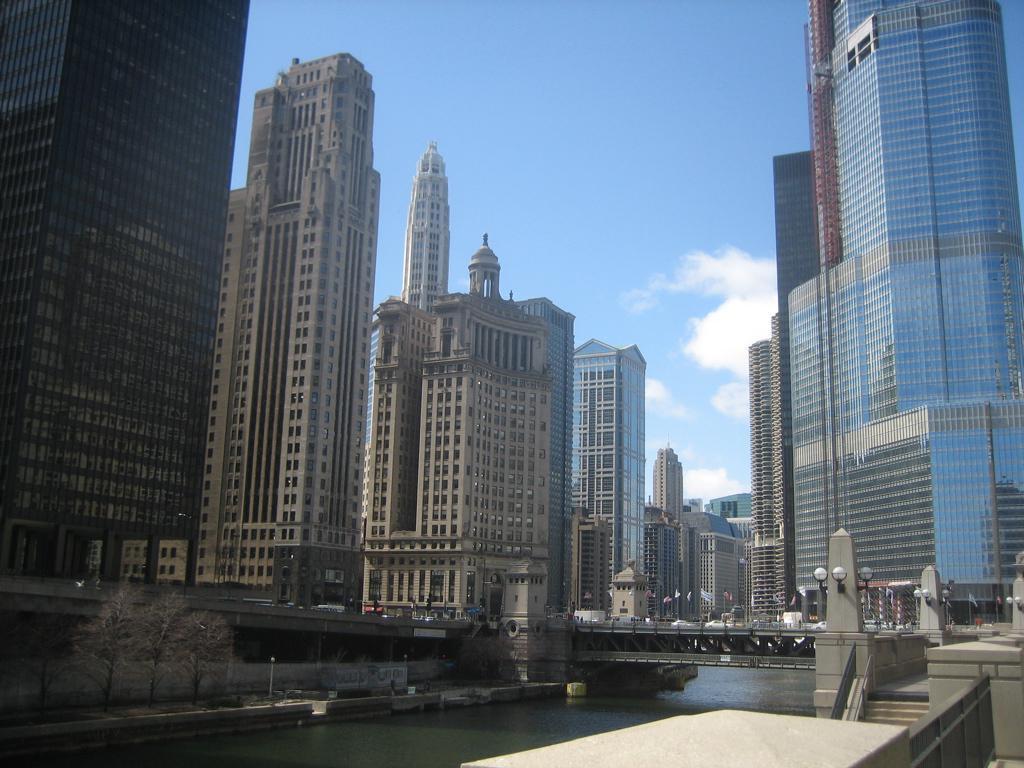Could you give a brief overview of what you see in this image? In the foreground of this image, on the bottom, there is railing, stairs and the lights. In the background, there is a bridge, few trees, side path, skyscrapers, sky and the cloud. 